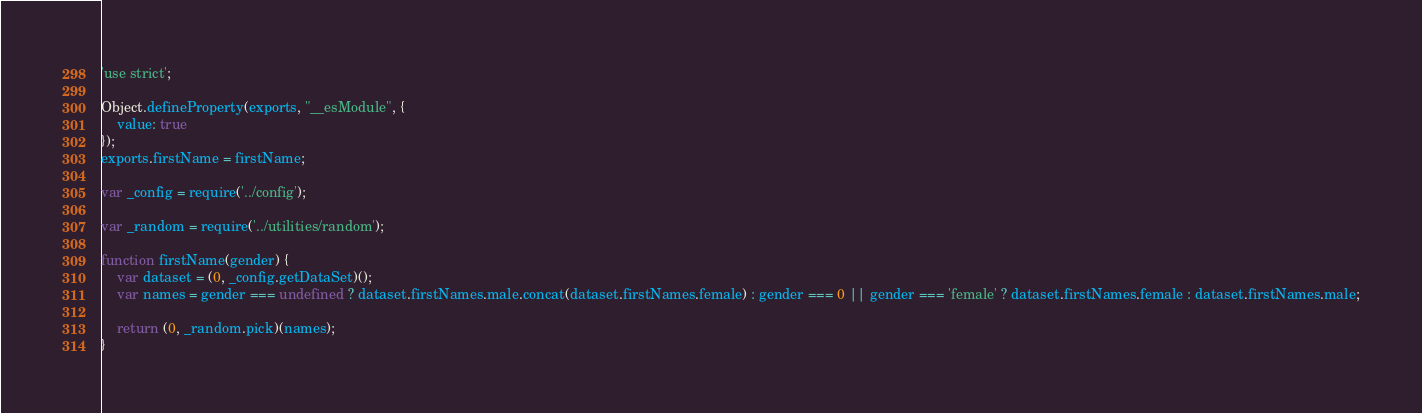<code> <loc_0><loc_0><loc_500><loc_500><_JavaScript_>'use strict';

Object.defineProperty(exports, "__esModule", {
    value: true
});
exports.firstName = firstName;

var _config = require('../config');

var _random = require('../utilities/random');

function firstName(gender) {
    var dataset = (0, _config.getDataSet)();
    var names = gender === undefined ? dataset.firstNames.male.concat(dataset.firstNames.female) : gender === 0 || gender === 'female' ? dataset.firstNames.female : dataset.firstNames.male;

    return (0, _random.pick)(names);
}</code> 